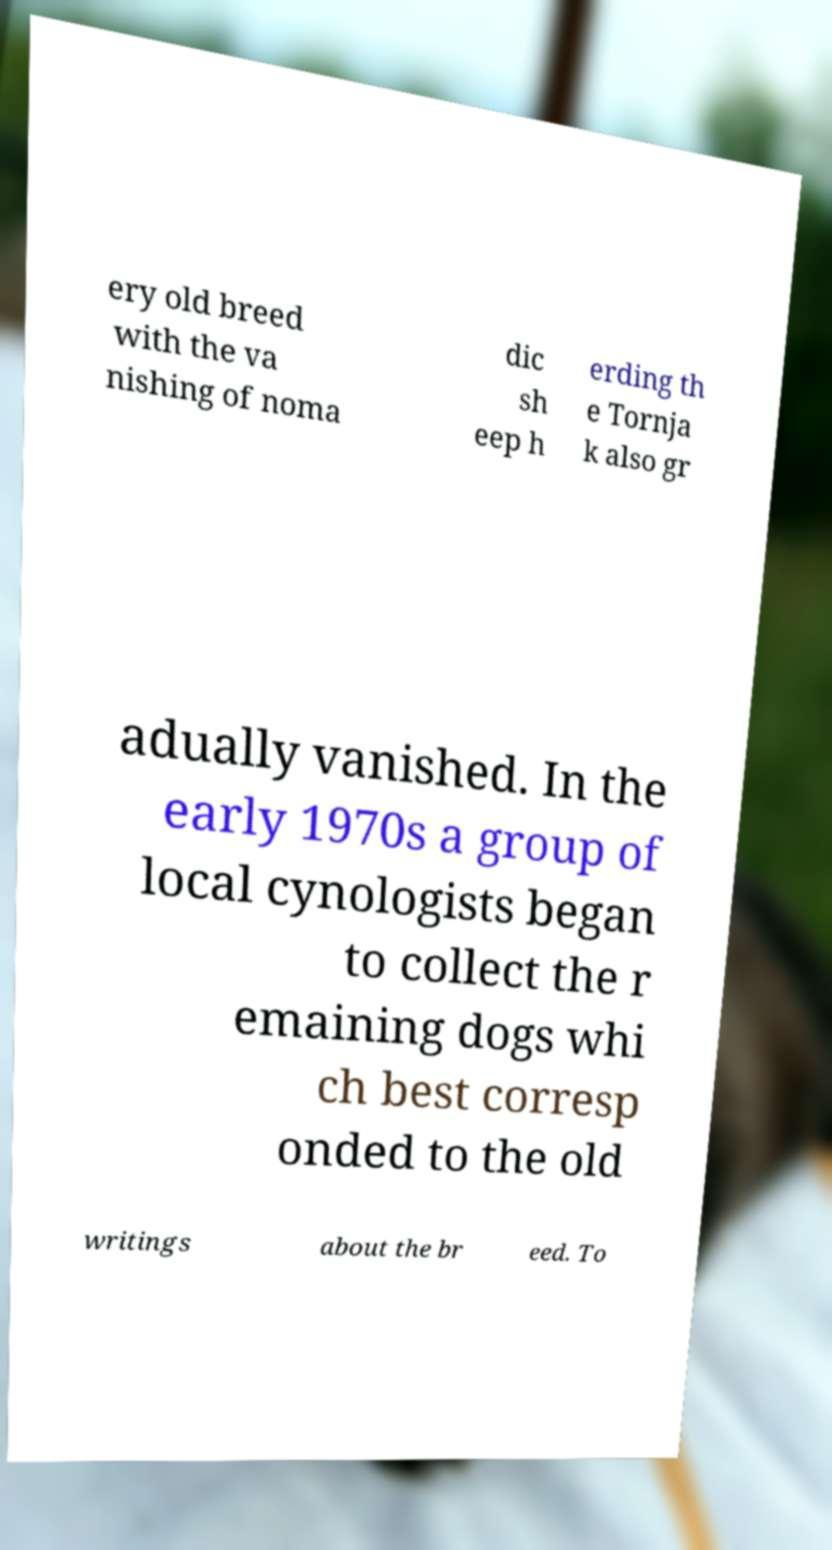There's text embedded in this image that I need extracted. Can you transcribe it verbatim? ery old breed with the va nishing of noma dic sh eep h erding th e Tornja k also gr adually vanished. In the early 1970s a group of local cynologists began to collect the r emaining dogs whi ch best corresp onded to the old writings about the br eed. To 